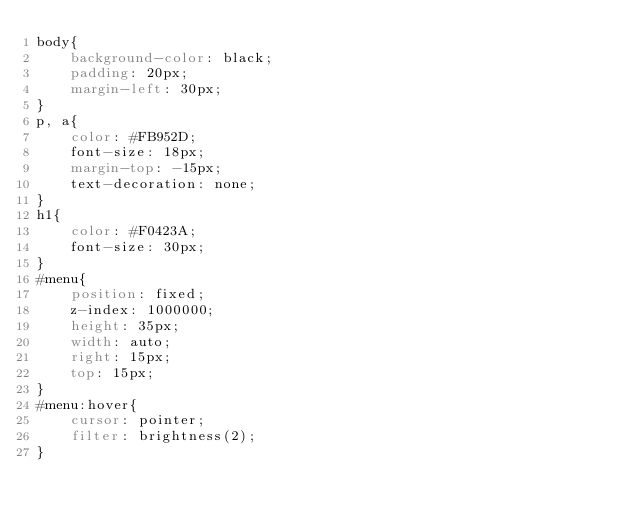<code> <loc_0><loc_0><loc_500><loc_500><_CSS_>body{
	background-color: black;
	padding: 20px; 
	margin-left: 30px;
}
p, a{
	color: #FB952D;
	font-size: 18px;
	margin-top: -15px;
	text-decoration: none;
}
h1{
	color: #F0423A;
	font-size: 30px;
}
#menu{
	position: fixed;
	z-index: 1000000;
	height: 35px;
	width: auto;
	right: 15px;
	top: 15px;
}
#menu:hover{
	cursor: pointer;
	filter: brightness(2);
}</code> 